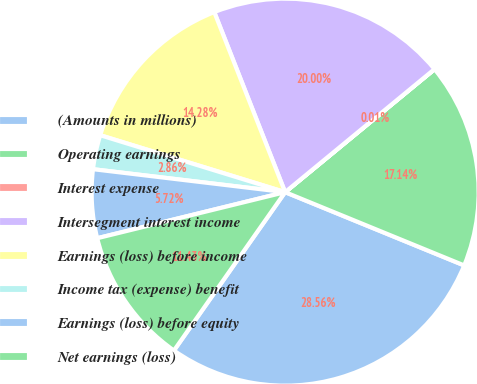Convert chart to OTSL. <chart><loc_0><loc_0><loc_500><loc_500><pie_chart><fcel>(Amounts in millions)<fcel>Operating earnings<fcel>Interest expense<fcel>Intersegment interest income<fcel>Earnings (loss) before income<fcel>Income tax (expense) benefit<fcel>Earnings (loss) before equity<fcel>Net earnings (loss)<nl><fcel>28.56%<fcel>17.14%<fcel>0.01%<fcel>20.0%<fcel>14.28%<fcel>2.86%<fcel>5.72%<fcel>11.43%<nl></chart> 